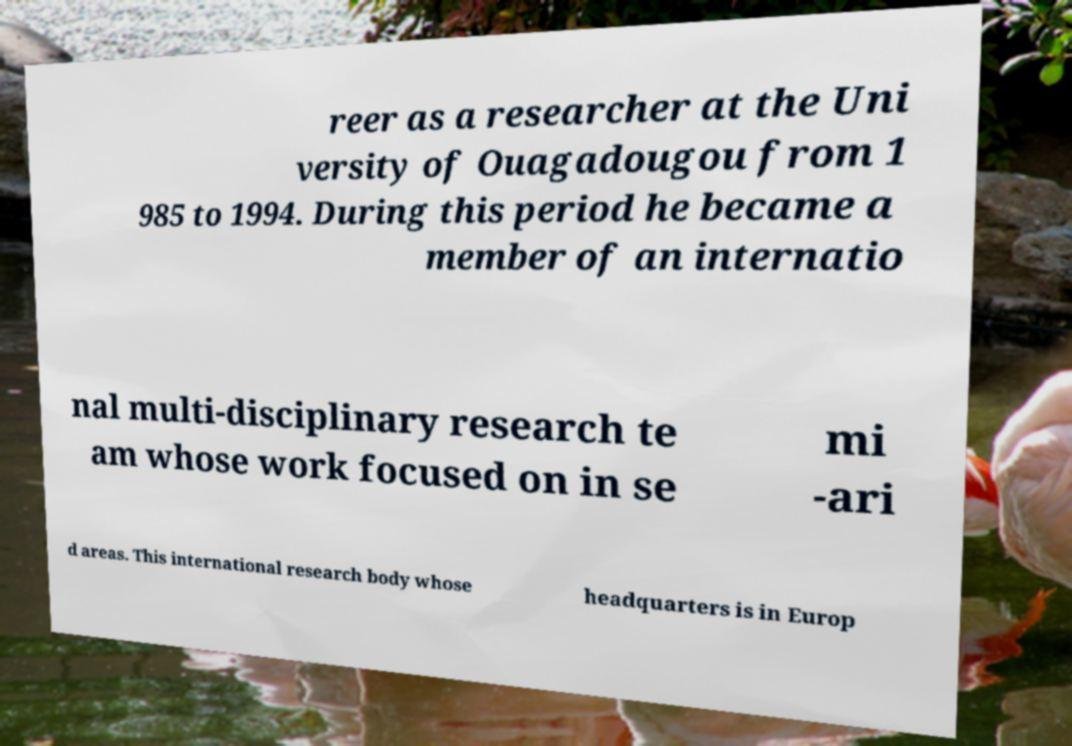Can you read and provide the text displayed in the image?This photo seems to have some interesting text. Can you extract and type it out for me? reer as a researcher at the Uni versity of Ouagadougou from 1 985 to 1994. During this period he became a member of an internatio nal multi-disciplinary research te am whose work focused on in se mi -ari d areas. This international research body whose headquarters is in Europ 